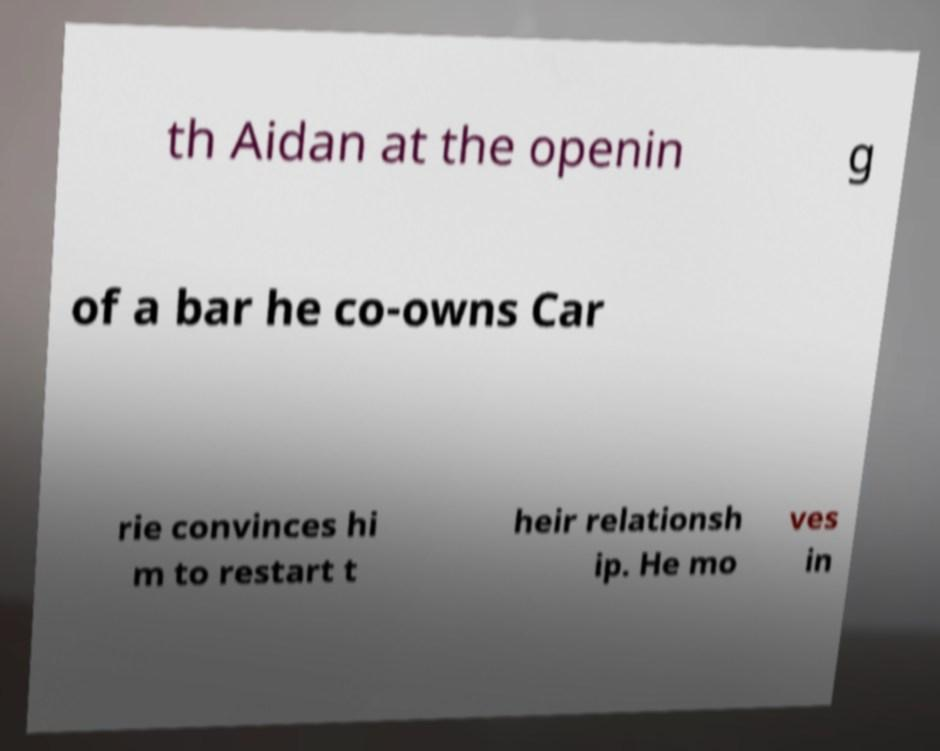There's text embedded in this image that I need extracted. Can you transcribe it verbatim? th Aidan at the openin g of a bar he co-owns Car rie convinces hi m to restart t heir relationsh ip. He mo ves in 